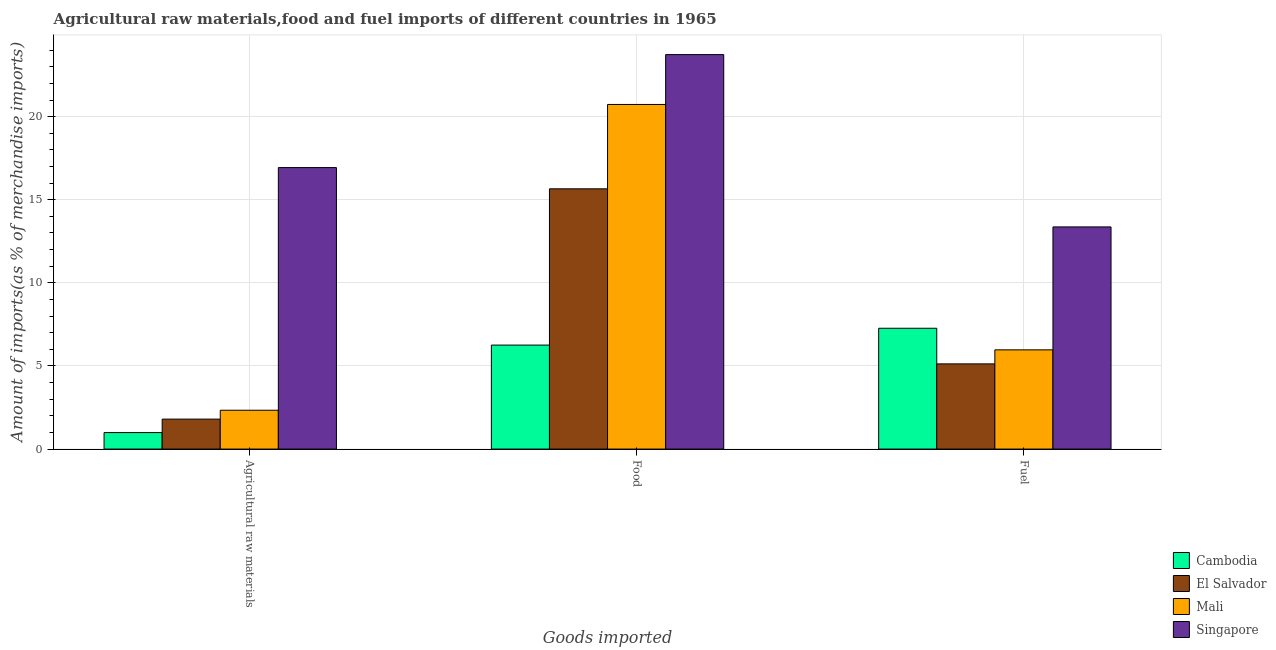How many different coloured bars are there?
Your answer should be compact. 4. Are the number of bars per tick equal to the number of legend labels?
Offer a terse response. Yes. How many bars are there on the 1st tick from the right?
Ensure brevity in your answer.  4. What is the label of the 1st group of bars from the left?
Provide a short and direct response. Agricultural raw materials. What is the percentage of fuel imports in Cambodia?
Make the answer very short. 7.27. Across all countries, what is the maximum percentage of raw materials imports?
Offer a very short reply. 16.93. Across all countries, what is the minimum percentage of raw materials imports?
Your response must be concise. 0.99. In which country was the percentage of raw materials imports maximum?
Your answer should be very brief. Singapore. In which country was the percentage of fuel imports minimum?
Your answer should be very brief. El Salvador. What is the total percentage of raw materials imports in the graph?
Give a very brief answer. 22.07. What is the difference between the percentage of food imports in Mali and that in Cambodia?
Keep it short and to the point. 14.48. What is the difference between the percentage of fuel imports in Cambodia and the percentage of raw materials imports in El Salvador?
Offer a very short reply. 5.47. What is the average percentage of fuel imports per country?
Keep it short and to the point. 7.93. What is the difference between the percentage of fuel imports and percentage of raw materials imports in Mali?
Your response must be concise. 3.63. What is the ratio of the percentage of fuel imports in Mali to that in Singapore?
Your answer should be compact. 0.45. Is the percentage of raw materials imports in Cambodia less than that in Mali?
Give a very brief answer. Yes. Is the difference between the percentage of raw materials imports in Cambodia and El Salvador greater than the difference between the percentage of food imports in Cambodia and El Salvador?
Offer a terse response. Yes. What is the difference between the highest and the second highest percentage of raw materials imports?
Make the answer very short. 14.6. What is the difference between the highest and the lowest percentage of raw materials imports?
Your answer should be very brief. 15.94. In how many countries, is the percentage of fuel imports greater than the average percentage of fuel imports taken over all countries?
Ensure brevity in your answer.  1. What does the 4th bar from the left in Food represents?
Your response must be concise. Singapore. What does the 1st bar from the right in Agricultural raw materials represents?
Provide a short and direct response. Singapore. Is it the case that in every country, the sum of the percentage of raw materials imports and percentage of food imports is greater than the percentage of fuel imports?
Offer a very short reply. No. How many bars are there?
Give a very brief answer. 12. What is the difference between two consecutive major ticks on the Y-axis?
Your answer should be very brief. 5. Are the values on the major ticks of Y-axis written in scientific E-notation?
Offer a terse response. No. Does the graph contain grids?
Ensure brevity in your answer.  Yes. Where does the legend appear in the graph?
Your answer should be compact. Bottom right. How are the legend labels stacked?
Provide a short and direct response. Vertical. What is the title of the graph?
Your response must be concise. Agricultural raw materials,food and fuel imports of different countries in 1965. Does "Yemen, Rep." appear as one of the legend labels in the graph?
Give a very brief answer. No. What is the label or title of the X-axis?
Your answer should be very brief. Goods imported. What is the label or title of the Y-axis?
Your answer should be compact. Amount of imports(as % of merchandise imports). What is the Amount of imports(as % of merchandise imports) in Cambodia in Agricultural raw materials?
Ensure brevity in your answer.  0.99. What is the Amount of imports(as % of merchandise imports) in El Salvador in Agricultural raw materials?
Your answer should be compact. 1.8. What is the Amount of imports(as % of merchandise imports) of Mali in Agricultural raw materials?
Your answer should be very brief. 2.34. What is the Amount of imports(as % of merchandise imports) in Singapore in Agricultural raw materials?
Your response must be concise. 16.93. What is the Amount of imports(as % of merchandise imports) of Cambodia in Food?
Make the answer very short. 6.26. What is the Amount of imports(as % of merchandise imports) in El Salvador in Food?
Keep it short and to the point. 15.66. What is the Amount of imports(as % of merchandise imports) of Mali in Food?
Your answer should be very brief. 20.73. What is the Amount of imports(as % of merchandise imports) of Singapore in Food?
Your response must be concise. 23.73. What is the Amount of imports(as % of merchandise imports) in Cambodia in Fuel?
Make the answer very short. 7.27. What is the Amount of imports(as % of merchandise imports) of El Salvador in Fuel?
Give a very brief answer. 5.13. What is the Amount of imports(as % of merchandise imports) in Mali in Fuel?
Provide a succinct answer. 5.97. What is the Amount of imports(as % of merchandise imports) in Singapore in Fuel?
Provide a short and direct response. 13.37. Across all Goods imported, what is the maximum Amount of imports(as % of merchandise imports) in Cambodia?
Give a very brief answer. 7.27. Across all Goods imported, what is the maximum Amount of imports(as % of merchandise imports) in El Salvador?
Offer a very short reply. 15.66. Across all Goods imported, what is the maximum Amount of imports(as % of merchandise imports) of Mali?
Ensure brevity in your answer.  20.73. Across all Goods imported, what is the maximum Amount of imports(as % of merchandise imports) of Singapore?
Offer a very short reply. 23.73. Across all Goods imported, what is the minimum Amount of imports(as % of merchandise imports) of Cambodia?
Your answer should be compact. 0.99. Across all Goods imported, what is the minimum Amount of imports(as % of merchandise imports) in El Salvador?
Ensure brevity in your answer.  1.8. Across all Goods imported, what is the minimum Amount of imports(as % of merchandise imports) of Mali?
Offer a terse response. 2.34. Across all Goods imported, what is the minimum Amount of imports(as % of merchandise imports) of Singapore?
Your response must be concise. 13.37. What is the total Amount of imports(as % of merchandise imports) in Cambodia in the graph?
Ensure brevity in your answer.  14.52. What is the total Amount of imports(as % of merchandise imports) of El Salvador in the graph?
Offer a very short reply. 22.58. What is the total Amount of imports(as % of merchandise imports) of Mali in the graph?
Ensure brevity in your answer.  29.04. What is the total Amount of imports(as % of merchandise imports) in Singapore in the graph?
Your answer should be very brief. 54.03. What is the difference between the Amount of imports(as % of merchandise imports) in Cambodia in Agricultural raw materials and that in Food?
Give a very brief answer. -5.26. What is the difference between the Amount of imports(as % of merchandise imports) of El Salvador in Agricultural raw materials and that in Food?
Offer a very short reply. -13.86. What is the difference between the Amount of imports(as % of merchandise imports) in Mali in Agricultural raw materials and that in Food?
Your answer should be very brief. -18.4. What is the difference between the Amount of imports(as % of merchandise imports) in Singapore in Agricultural raw materials and that in Food?
Your answer should be compact. -6.8. What is the difference between the Amount of imports(as % of merchandise imports) of Cambodia in Agricultural raw materials and that in Fuel?
Your answer should be compact. -6.27. What is the difference between the Amount of imports(as % of merchandise imports) in El Salvador in Agricultural raw materials and that in Fuel?
Give a very brief answer. -3.32. What is the difference between the Amount of imports(as % of merchandise imports) of Mali in Agricultural raw materials and that in Fuel?
Your answer should be very brief. -3.63. What is the difference between the Amount of imports(as % of merchandise imports) of Singapore in Agricultural raw materials and that in Fuel?
Your response must be concise. 3.57. What is the difference between the Amount of imports(as % of merchandise imports) in Cambodia in Food and that in Fuel?
Provide a succinct answer. -1.01. What is the difference between the Amount of imports(as % of merchandise imports) of El Salvador in Food and that in Fuel?
Your answer should be compact. 10.53. What is the difference between the Amount of imports(as % of merchandise imports) of Mali in Food and that in Fuel?
Make the answer very short. 14.76. What is the difference between the Amount of imports(as % of merchandise imports) of Singapore in Food and that in Fuel?
Offer a terse response. 10.37. What is the difference between the Amount of imports(as % of merchandise imports) of Cambodia in Agricultural raw materials and the Amount of imports(as % of merchandise imports) of El Salvador in Food?
Give a very brief answer. -14.66. What is the difference between the Amount of imports(as % of merchandise imports) in Cambodia in Agricultural raw materials and the Amount of imports(as % of merchandise imports) in Mali in Food?
Ensure brevity in your answer.  -19.74. What is the difference between the Amount of imports(as % of merchandise imports) of Cambodia in Agricultural raw materials and the Amount of imports(as % of merchandise imports) of Singapore in Food?
Make the answer very short. -22.74. What is the difference between the Amount of imports(as % of merchandise imports) of El Salvador in Agricultural raw materials and the Amount of imports(as % of merchandise imports) of Mali in Food?
Keep it short and to the point. -18.93. What is the difference between the Amount of imports(as % of merchandise imports) in El Salvador in Agricultural raw materials and the Amount of imports(as % of merchandise imports) in Singapore in Food?
Give a very brief answer. -21.93. What is the difference between the Amount of imports(as % of merchandise imports) of Mali in Agricultural raw materials and the Amount of imports(as % of merchandise imports) of Singapore in Food?
Make the answer very short. -21.4. What is the difference between the Amount of imports(as % of merchandise imports) of Cambodia in Agricultural raw materials and the Amount of imports(as % of merchandise imports) of El Salvador in Fuel?
Provide a succinct answer. -4.13. What is the difference between the Amount of imports(as % of merchandise imports) in Cambodia in Agricultural raw materials and the Amount of imports(as % of merchandise imports) in Mali in Fuel?
Offer a terse response. -4.98. What is the difference between the Amount of imports(as % of merchandise imports) of Cambodia in Agricultural raw materials and the Amount of imports(as % of merchandise imports) of Singapore in Fuel?
Offer a very short reply. -12.37. What is the difference between the Amount of imports(as % of merchandise imports) of El Salvador in Agricultural raw materials and the Amount of imports(as % of merchandise imports) of Mali in Fuel?
Offer a terse response. -4.17. What is the difference between the Amount of imports(as % of merchandise imports) of El Salvador in Agricultural raw materials and the Amount of imports(as % of merchandise imports) of Singapore in Fuel?
Provide a short and direct response. -11.56. What is the difference between the Amount of imports(as % of merchandise imports) of Mali in Agricultural raw materials and the Amount of imports(as % of merchandise imports) of Singapore in Fuel?
Offer a terse response. -11.03. What is the difference between the Amount of imports(as % of merchandise imports) in Cambodia in Food and the Amount of imports(as % of merchandise imports) in El Salvador in Fuel?
Make the answer very short. 1.13. What is the difference between the Amount of imports(as % of merchandise imports) of Cambodia in Food and the Amount of imports(as % of merchandise imports) of Mali in Fuel?
Give a very brief answer. 0.29. What is the difference between the Amount of imports(as % of merchandise imports) of Cambodia in Food and the Amount of imports(as % of merchandise imports) of Singapore in Fuel?
Provide a short and direct response. -7.11. What is the difference between the Amount of imports(as % of merchandise imports) in El Salvador in Food and the Amount of imports(as % of merchandise imports) in Mali in Fuel?
Your response must be concise. 9.69. What is the difference between the Amount of imports(as % of merchandise imports) in El Salvador in Food and the Amount of imports(as % of merchandise imports) in Singapore in Fuel?
Give a very brief answer. 2.29. What is the difference between the Amount of imports(as % of merchandise imports) of Mali in Food and the Amount of imports(as % of merchandise imports) of Singapore in Fuel?
Provide a succinct answer. 7.37. What is the average Amount of imports(as % of merchandise imports) of Cambodia per Goods imported?
Provide a succinct answer. 4.84. What is the average Amount of imports(as % of merchandise imports) of El Salvador per Goods imported?
Give a very brief answer. 7.53. What is the average Amount of imports(as % of merchandise imports) in Mali per Goods imported?
Ensure brevity in your answer.  9.68. What is the average Amount of imports(as % of merchandise imports) in Singapore per Goods imported?
Provide a short and direct response. 18.01. What is the difference between the Amount of imports(as % of merchandise imports) of Cambodia and Amount of imports(as % of merchandise imports) of El Salvador in Agricultural raw materials?
Offer a terse response. -0.81. What is the difference between the Amount of imports(as % of merchandise imports) of Cambodia and Amount of imports(as % of merchandise imports) of Mali in Agricultural raw materials?
Offer a very short reply. -1.34. What is the difference between the Amount of imports(as % of merchandise imports) of Cambodia and Amount of imports(as % of merchandise imports) of Singapore in Agricultural raw materials?
Your response must be concise. -15.94. What is the difference between the Amount of imports(as % of merchandise imports) of El Salvador and Amount of imports(as % of merchandise imports) of Mali in Agricultural raw materials?
Keep it short and to the point. -0.53. What is the difference between the Amount of imports(as % of merchandise imports) in El Salvador and Amount of imports(as % of merchandise imports) in Singapore in Agricultural raw materials?
Make the answer very short. -15.13. What is the difference between the Amount of imports(as % of merchandise imports) in Mali and Amount of imports(as % of merchandise imports) in Singapore in Agricultural raw materials?
Provide a succinct answer. -14.6. What is the difference between the Amount of imports(as % of merchandise imports) of Cambodia and Amount of imports(as % of merchandise imports) of El Salvador in Food?
Offer a very short reply. -9.4. What is the difference between the Amount of imports(as % of merchandise imports) of Cambodia and Amount of imports(as % of merchandise imports) of Mali in Food?
Keep it short and to the point. -14.48. What is the difference between the Amount of imports(as % of merchandise imports) of Cambodia and Amount of imports(as % of merchandise imports) of Singapore in Food?
Provide a succinct answer. -17.48. What is the difference between the Amount of imports(as % of merchandise imports) in El Salvador and Amount of imports(as % of merchandise imports) in Mali in Food?
Offer a very short reply. -5.08. What is the difference between the Amount of imports(as % of merchandise imports) in El Salvador and Amount of imports(as % of merchandise imports) in Singapore in Food?
Your response must be concise. -8.07. What is the difference between the Amount of imports(as % of merchandise imports) in Mali and Amount of imports(as % of merchandise imports) in Singapore in Food?
Provide a succinct answer. -3. What is the difference between the Amount of imports(as % of merchandise imports) in Cambodia and Amount of imports(as % of merchandise imports) in El Salvador in Fuel?
Provide a succinct answer. 2.14. What is the difference between the Amount of imports(as % of merchandise imports) in Cambodia and Amount of imports(as % of merchandise imports) in Mali in Fuel?
Ensure brevity in your answer.  1.3. What is the difference between the Amount of imports(as % of merchandise imports) in Cambodia and Amount of imports(as % of merchandise imports) in Singapore in Fuel?
Give a very brief answer. -6.1. What is the difference between the Amount of imports(as % of merchandise imports) of El Salvador and Amount of imports(as % of merchandise imports) of Mali in Fuel?
Your answer should be very brief. -0.84. What is the difference between the Amount of imports(as % of merchandise imports) of El Salvador and Amount of imports(as % of merchandise imports) of Singapore in Fuel?
Offer a terse response. -8.24. What is the difference between the Amount of imports(as % of merchandise imports) in Mali and Amount of imports(as % of merchandise imports) in Singapore in Fuel?
Provide a short and direct response. -7.4. What is the ratio of the Amount of imports(as % of merchandise imports) in Cambodia in Agricultural raw materials to that in Food?
Provide a short and direct response. 0.16. What is the ratio of the Amount of imports(as % of merchandise imports) in El Salvador in Agricultural raw materials to that in Food?
Your response must be concise. 0.12. What is the ratio of the Amount of imports(as % of merchandise imports) of Mali in Agricultural raw materials to that in Food?
Your response must be concise. 0.11. What is the ratio of the Amount of imports(as % of merchandise imports) of Singapore in Agricultural raw materials to that in Food?
Offer a terse response. 0.71. What is the ratio of the Amount of imports(as % of merchandise imports) in Cambodia in Agricultural raw materials to that in Fuel?
Make the answer very short. 0.14. What is the ratio of the Amount of imports(as % of merchandise imports) in El Salvador in Agricultural raw materials to that in Fuel?
Provide a short and direct response. 0.35. What is the ratio of the Amount of imports(as % of merchandise imports) of Mali in Agricultural raw materials to that in Fuel?
Your response must be concise. 0.39. What is the ratio of the Amount of imports(as % of merchandise imports) of Singapore in Agricultural raw materials to that in Fuel?
Your response must be concise. 1.27. What is the ratio of the Amount of imports(as % of merchandise imports) in Cambodia in Food to that in Fuel?
Keep it short and to the point. 0.86. What is the ratio of the Amount of imports(as % of merchandise imports) in El Salvador in Food to that in Fuel?
Your answer should be very brief. 3.05. What is the ratio of the Amount of imports(as % of merchandise imports) of Mali in Food to that in Fuel?
Your answer should be compact. 3.47. What is the ratio of the Amount of imports(as % of merchandise imports) of Singapore in Food to that in Fuel?
Give a very brief answer. 1.78. What is the difference between the highest and the second highest Amount of imports(as % of merchandise imports) in Cambodia?
Make the answer very short. 1.01. What is the difference between the highest and the second highest Amount of imports(as % of merchandise imports) in El Salvador?
Offer a very short reply. 10.53. What is the difference between the highest and the second highest Amount of imports(as % of merchandise imports) of Mali?
Offer a terse response. 14.76. What is the difference between the highest and the second highest Amount of imports(as % of merchandise imports) in Singapore?
Offer a very short reply. 6.8. What is the difference between the highest and the lowest Amount of imports(as % of merchandise imports) of Cambodia?
Keep it short and to the point. 6.27. What is the difference between the highest and the lowest Amount of imports(as % of merchandise imports) in El Salvador?
Offer a terse response. 13.86. What is the difference between the highest and the lowest Amount of imports(as % of merchandise imports) in Mali?
Provide a short and direct response. 18.4. What is the difference between the highest and the lowest Amount of imports(as % of merchandise imports) of Singapore?
Keep it short and to the point. 10.37. 